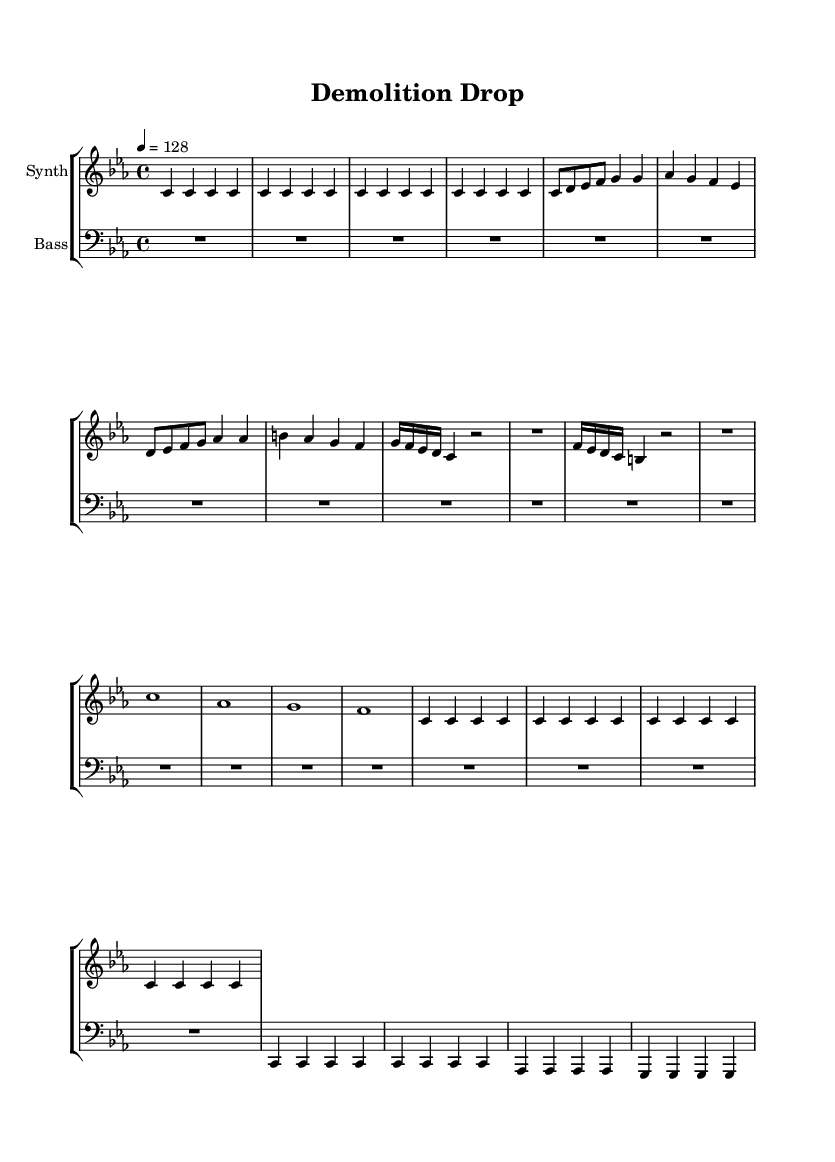What is the key signature of this music? The key signature is C minor, which has three flats (B-flat, E-flat, and A-flat). This can be identified by looking at the key signature indicated at the beginning of the score.
Answer: C minor What is the time signature of the piece? The time signature is 4/4, which is the most common time signature in music. This is noted at the beginning of the score just after the key signature.
Answer: 4/4 What is the tempo marking of the piece? The tempo marking is 128 beats per minute (BPM), indicated in the header of the score where it states "4 = 128". This tells the performer the speed of the music.
Answer: 128 How many measures are in the synth intro? The synth intro consists of 4 measures, as indicated by the repetition notation "\repeat unfold 4". This means the material within that section is repeated four times, totaling 4 measures.
Answer: 4 What is the stylistic feature of the bass drop section? The bass drop section prominently features quarter notes on the bass line, creating a low, steady pulse characteristic of heavy bass drops in techno music. The repetition of the notes contributes to a driving rhythm.
Answer: Quarter notes What musical element does the "synth drop" section mimic? The "synth drop" section mimics the impact of demolition and new construction through its use of sudden changes in dynamics and rhythm, reflecting the explosive nature of these events with abrupt rests and strong accents.
Answer: Explosive dynamics 